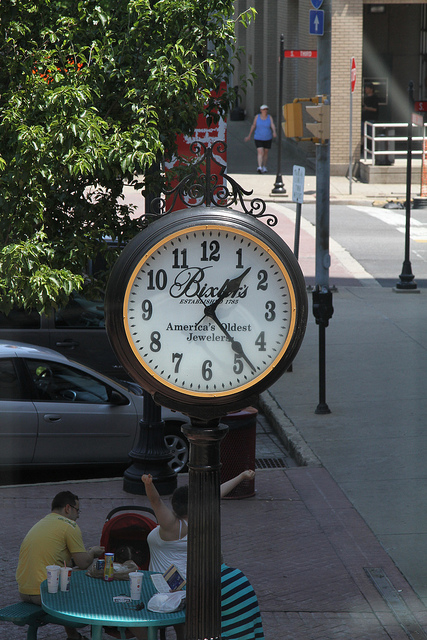Read all the text in this image. 7 BIX 2 5 3 Jewelery 4 6 Oldest America's 8 9 10 11 1 12 